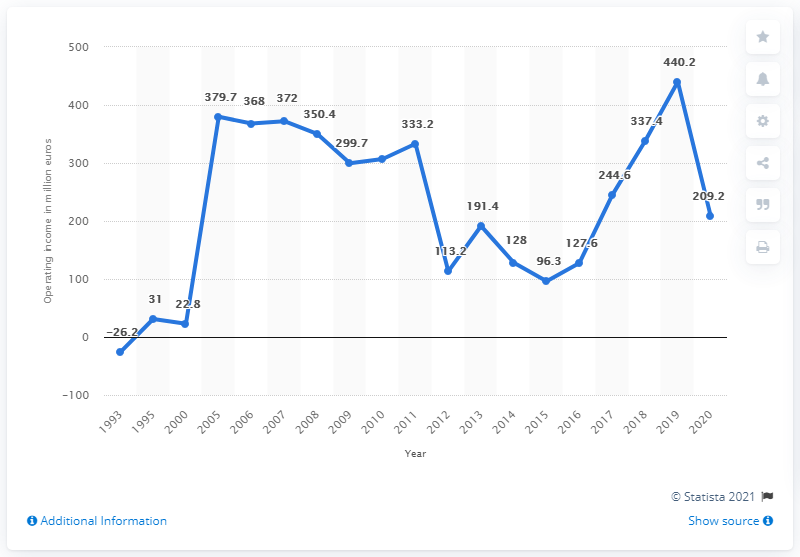Can you provide a summary of the trend in operating income from 1993 to 2007? The line graph shows a trend where the operating income started at a loss in 1993, followed by a steady increase peaking in 1997. After a few fluctuations, there's a steep drop around 2001, and then a recovery with some ups and downs culminating in a high point in 2007.  What could be the reason for the sharp decrease in 2001? The sharp decrease in operating income in 2001 might indicate a challenging economic period, such as a recession, or it could be reflective of industry-specific issues, changes in management strategies, or significant expenses the company faced that year. 